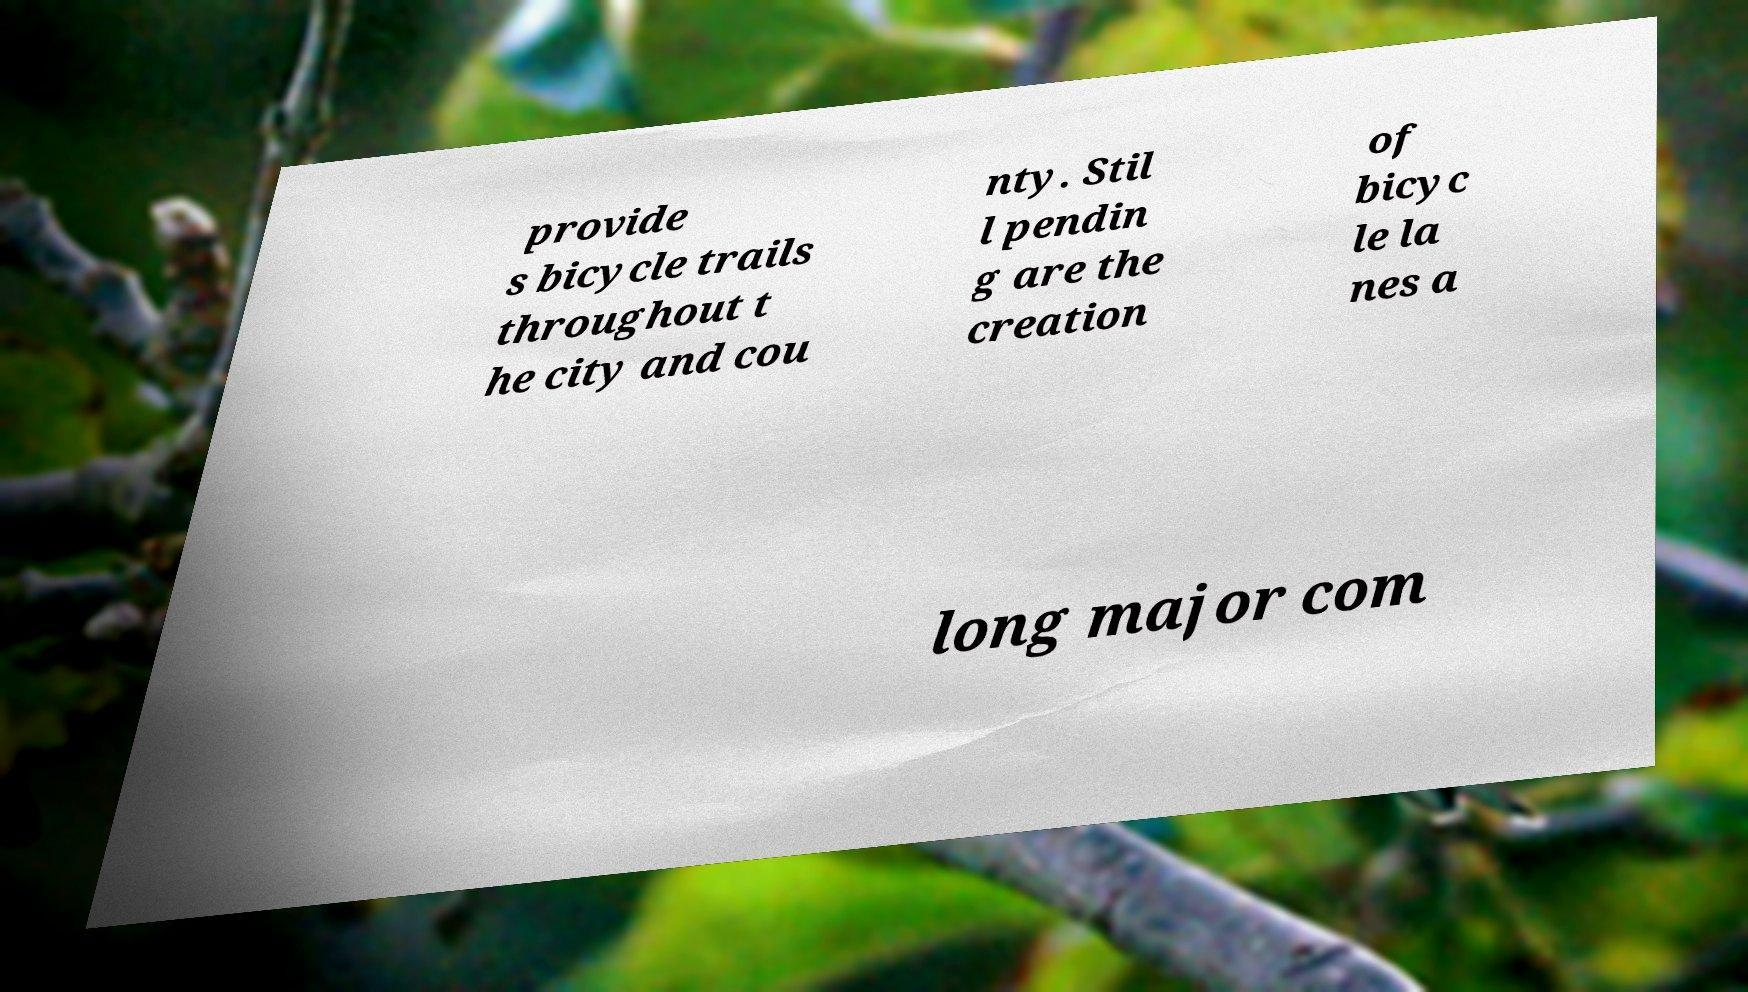What messages or text are displayed in this image? I need them in a readable, typed format. provide s bicycle trails throughout t he city and cou nty. Stil l pendin g are the creation of bicyc le la nes a long major com 